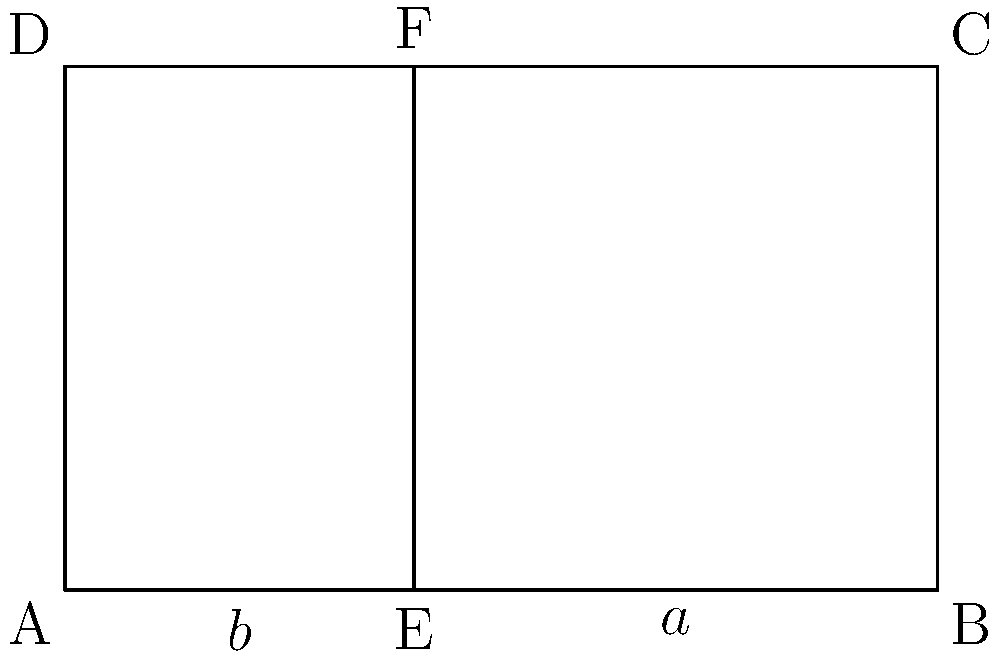In a traditional temple from your parent's homeland, the front facade is shaped like a rectangle with a vertical line dividing it into two sections. The width of the entire facade is 5 meters, and its height is 3 meters. If the division follows the golden ratio, what is the length of the smaller section (labeled as $b$ in the diagram) to the nearest centimeter? To solve this problem, we'll use the properties of the golden ratio and the given dimensions:

1) The golden ratio is defined as $\phi = \frac{a+b}{a} = \frac{a}{b} \approx 1.618$, where $a$ is the longer segment and $b$ is the shorter segment.

2) We know that the total width of the facade is 5 meters, so $a + b = 5$.

3) Using the golden ratio property, we can write:
   $\frac{a}{b} = \phi$

4) We can express $a$ in terms of $b$:
   $a = 5 - b$

5) Substituting this into the golden ratio equation:
   $\frac{5-b}{b} = \phi$

6) Solving for $b$:
   $5-b = \phi b$
   $5 = \phi b + b = b(\phi + 1)$
   $b = \frac{5}{\phi + 1}$

7) We know that $\phi \approx 1.618$, so:
   $b = \frac{5}{1.618 + 1} = \frac{5}{2.618} \approx 1.91$ meters

8) Converting to centimeters: $1.91$ meters = 191 centimeters

Therefore, the length of the smaller section ($b$) is approximately 191 cm.
Answer: 191 cm 